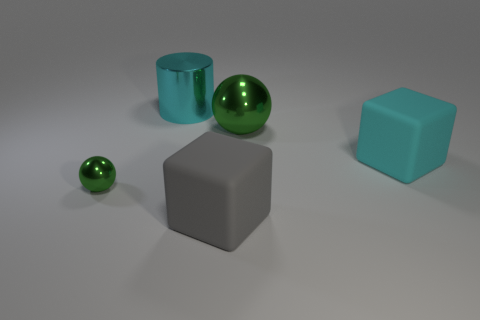How many green spheres must be subtracted to get 1 green spheres? 1 Add 2 gray shiny cylinders. How many objects exist? 7 Subtract all balls. How many objects are left? 3 Subtract all small cyan rubber balls. Subtract all small things. How many objects are left? 4 Add 5 green shiny balls. How many green shiny balls are left? 7 Add 2 large purple cylinders. How many large purple cylinders exist? 2 Subtract 0 purple cylinders. How many objects are left? 5 